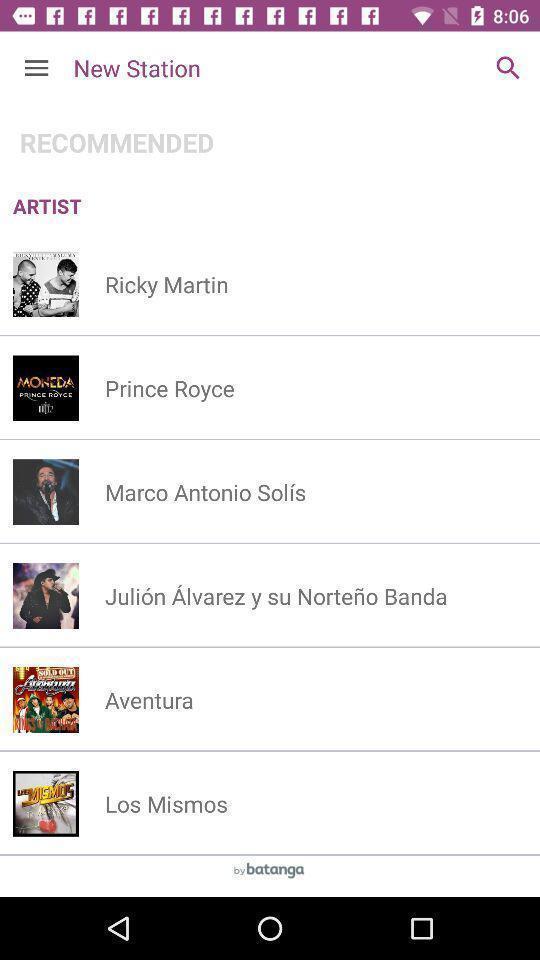Provide a textual representation of this image. Screen shows recommended artist list in music app. 